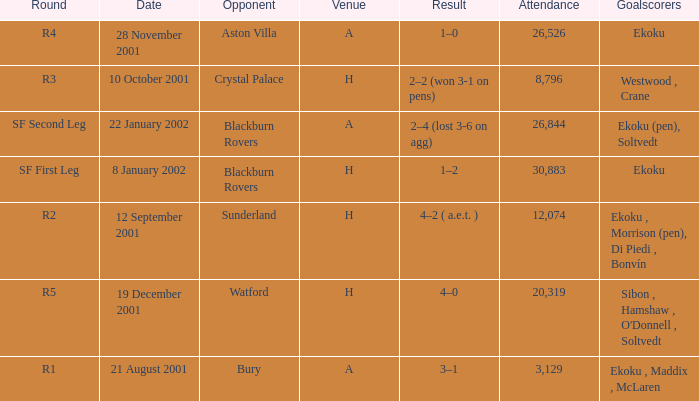Which venue has attendance larger than 26,526, and sf first leg round? H. 